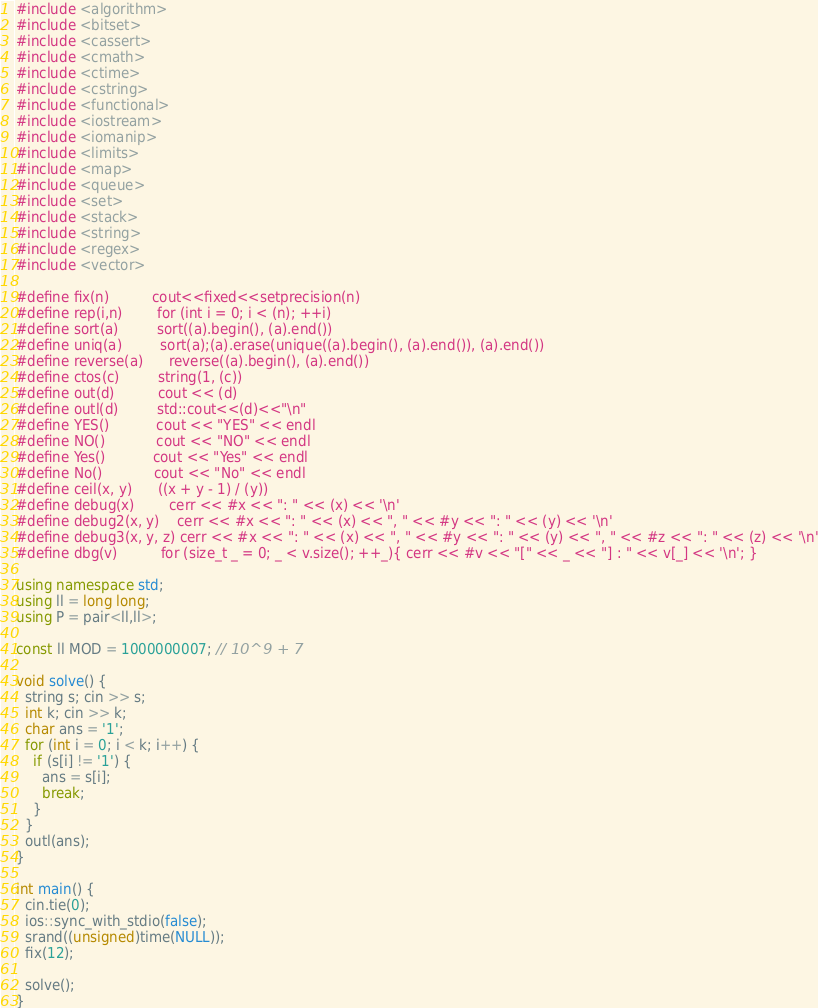<code> <loc_0><loc_0><loc_500><loc_500><_C++_>#include <algorithm>
#include <bitset>
#include <cassert>
#include <cmath>
#include <ctime>
#include <cstring>
#include <functional>
#include <iostream>
#include <iomanip>
#include <limits>
#include <map>
#include <queue>
#include <set>
#include <stack>
#include <string>
#include <regex>
#include <vector>

#define fix(n)          cout<<fixed<<setprecision(n)
#define rep(i,n)        for (int i = 0; i < (n); ++i)
#define sort(a)         sort((a).begin(), (a).end())
#define uniq(a)         sort(a);(a).erase(unique((a).begin(), (a).end()), (a).end())
#define reverse(a)      reverse((a).begin(), (a).end())
#define ctos(c)         string(1, (c))
#define out(d)          cout << (d)
#define outl(d)         std::cout<<(d)<<"\n"
#define YES()           cout << "YES" << endl
#define NO()            cout << "NO" << endl
#define Yes()           cout << "Yes" << endl
#define No()            cout << "No" << endl
#define ceil(x, y)      ((x + y - 1) / (y))
#define debug(x)        cerr << #x << ": " << (x) << '\n'
#define debug2(x, y)    cerr << #x << ": " << (x) << ", " << #y << ": " << (y) << '\n'
#define debug3(x, y, z) cerr << #x << ": " << (x) << ", " << #y << ": " << (y) << ", " << #z << ": " << (z) << '\n'
#define dbg(v)          for (size_t _ = 0; _ < v.size(); ++_){ cerr << #v << "[" << _ << "] : " << v[_] << '\n'; }

using namespace std;
using ll = long long;
using P = pair<ll,ll>;

const ll MOD = 1000000007; // 10^9 + 7

void solve() {
  string s; cin >> s;
  int k; cin >> k;
  char ans = '1';
  for (int i = 0; i < k; i++) {
    if (s[i] != '1') {
      ans = s[i];
      break;
    }
  }
  outl(ans);
}

int main() {
  cin.tie(0);
  ios::sync_with_stdio(false);
  srand((unsigned)time(NULL));
  fix(12);

  solve();
}
</code> 